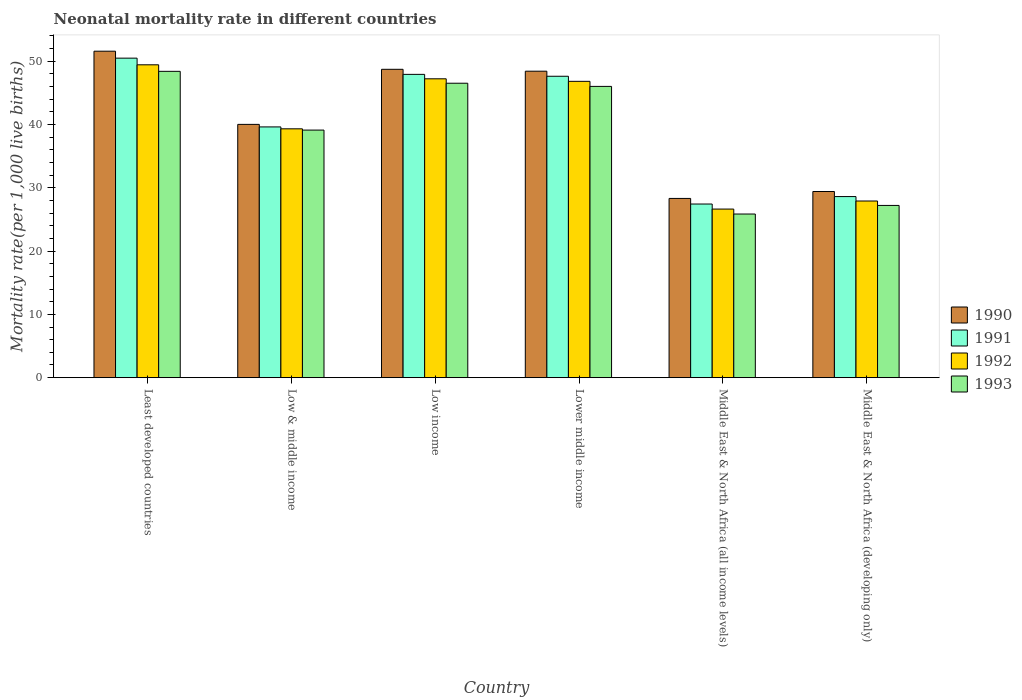Are the number of bars per tick equal to the number of legend labels?
Make the answer very short. Yes. Are the number of bars on each tick of the X-axis equal?
Keep it short and to the point. Yes. How many bars are there on the 4th tick from the left?
Make the answer very short. 4. How many bars are there on the 2nd tick from the right?
Keep it short and to the point. 4. What is the label of the 2nd group of bars from the left?
Keep it short and to the point. Low & middle income. In how many cases, is the number of bars for a given country not equal to the number of legend labels?
Give a very brief answer. 0. What is the neonatal mortality rate in 1992 in Middle East & North Africa (all income levels)?
Give a very brief answer. 26.63. Across all countries, what is the maximum neonatal mortality rate in 1992?
Ensure brevity in your answer.  49.41. Across all countries, what is the minimum neonatal mortality rate in 1990?
Your answer should be compact. 28.31. In which country was the neonatal mortality rate in 1991 maximum?
Ensure brevity in your answer.  Least developed countries. In which country was the neonatal mortality rate in 1990 minimum?
Your response must be concise. Middle East & North Africa (all income levels). What is the total neonatal mortality rate in 1990 in the graph?
Ensure brevity in your answer.  246.36. What is the difference between the neonatal mortality rate in 1993 in Low & middle income and that in Middle East & North Africa (developing only)?
Give a very brief answer. 11.9. What is the difference between the neonatal mortality rate in 1992 in Low income and the neonatal mortality rate in 1990 in Middle East & North Africa (developing only)?
Keep it short and to the point. 17.8. What is the average neonatal mortality rate in 1993 per country?
Keep it short and to the point. 38.84. What is the difference between the neonatal mortality rate of/in 1990 and neonatal mortality rate of/in 1993 in Middle East & North Africa (developing only)?
Your answer should be compact. 2.2. In how many countries, is the neonatal mortality rate in 1990 greater than 50?
Provide a succinct answer. 1. What is the ratio of the neonatal mortality rate in 1991 in Low income to that in Middle East & North Africa (all income levels)?
Your answer should be compact. 1.75. Is the neonatal mortality rate in 1992 in Lower middle income less than that in Middle East & North Africa (developing only)?
Provide a short and direct response. No. What is the difference between the highest and the second highest neonatal mortality rate in 1991?
Ensure brevity in your answer.  2.86. What is the difference between the highest and the lowest neonatal mortality rate in 1993?
Your answer should be very brief. 22.54. In how many countries, is the neonatal mortality rate in 1991 greater than the average neonatal mortality rate in 1991 taken over all countries?
Your answer should be very brief. 3. Is it the case that in every country, the sum of the neonatal mortality rate in 1993 and neonatal mortality rate in 1991 is greater than the sum of neonatal mortality rate in 1992 and neonatal mortality rate in 1990?
Provide a short and direct response. No. How many bars are there?
Ensure brevity in your answer.  24. How many countries are there in the graph?
Keep it short and to the point. 6. Are the values on the major ticks of Y-axis written in scientific E-notation?
Your answer should be very brief. No. Does the graph contain grids?
Give a very brief answer. No. How many legend labels are there?
Offer a very short reply. 4. How are the legend labels stacked?
Provide a short and direct response. Vertical. What is the title of the graph?
Offer a very short reply. Neonatal mortality rate in different countries. Does "2010" appear as one of the legend labels in the graph?
Keep it short and to the point. No. What is the label or title of the X-axis?
Provide a succinct answer. Country. What is the label or title of the Y-axis?
Your response must be concise. Mortality rate(per 1,0 live births). What is the Mortality rate(per 1,000 live births) of 1990 in Least developed countries?
Keep it short and to the point. 51.56. What is the Mortality rate(per 1,000 live births) of 1991 in Least developed countries?
Make the answer very short. 50.46. What is the Mortality rate(per 1,000 live births) of 1992 in Least developed countries?
Keep it short and to the point. 49.41. What is the Mortality rate(per 1,000 live births) in 1993 in Least developed countries?
Your response must be concise. 48.38. What is the Mortality rate(per 1,000 live births) in 1991 in Low & middle income?
Provide a succinct answer. 39.6. What is the Mortality rate(per 1,000 live births) in 1992 in Low & middle income?
Offer a terse response. 39.3. What is the Mortality rate(per 1,000 live births) of 1993 in Low & middle income?
Your answer should be compact. 39.1. What is the Mortality rate(per 1,000 live births) of 1990 in Low income?
Give a very brief answer. 48.7. What is the Mortality rate(per 1,000 live births) of 1991 in Low income?
Provide a short and direct response. 47.9. What is the Mortality rate(per 1,000 live births) of 1992 in Low income?
Provide a succinct answer. 47.2. What is the Mortality rate(per 1,000 live births) in 1993 in Low income?
Your answer should be compact. 46.5. What is the Mortality rate(per 1,000 live births) of 1990 in Lower middle income?
Provide a short and direct response. 48.4. What is the Mortality rate(per 1,000 live births) of 1991 in Lower middle income?
Your answer should be compact. 47.6. What is the Mortality rate(per 1,000 live births) of 1992 in Lower middle income?
Make the answer very short. 46.8. What is the Mortality rate(per 1,000 live births) in 1993 in Lower middle income?
Offer a terse response. 46. What is the Mortality rate(per 1,000 live births) in 1990 in Middle East & North Africa (all income levels)?
Keep it short and to the point. 28.31. What is the Mortality rate(per 1,000 live births) of 1991 in Middle East & North Africa (all income levels)?
Make the answer very short. 27.42. What is the Mortality rate(per 1,000 live births) of 1992 in Middle East & North Africa (all income levels)?
Give a very brief answer. 26.63. What is the Mortality rate(per 1,000 live births) of 1993 in Middle East & North Africa (all income levels)?
Provide a short and direct response. 25.84. What is the Mortality rate(per 1,000 live births) in 1990 in Middle East & North Africa (developing only)?
Your response must be concise. 29.4. What is the Mortality rate(per 1,000 live births) in 1991 in Middle East & North Africa (developing only)?
Your response must be concise. 28.6. What is the Mortality rate(per 1,000 live births) of 1992 in Middle East & North Africa (developing only)?
Make the answer very short. 27.9. What is the Mortality rate(per 1,000 live births) of 1993 in Middle East & North Africa (developing only)?
Give a very brief answer. 27.2. Across all countries, what is the maximum Mortality rate(per 1,000 live births) in 1990?
Provide a short and direct response. 51.56. Across all countries, what is the maximum Mortality rate(per 1,000 live births) of 1991?
Offer a terse response. 50.46. Across all countries, what is the maximum Mortality rate(per 1,000 live births) in 1992?
Offer a very short reply. 49.41. Across all countries, what is the maximum Mortality rate(per 1,000 live births) in 1993?
Your response must be concise. 48.38. Across all countries, what is the minimum Mortality rate(per 1,000 live births) of 1990?
Offer a terse response. 28.31. Across all countries, what is the minimum Mortality rate(per 1,000 live births) of 1991?
Provide a succinct answer. 27.42. Across all countries, what is the minimum Mortality rate(per 1,000 live births) in 1992?
Keep it short and to the point. 26.63. Across all countries, what is the minimum Mortality rate(per 1,000 live births) in 1993?
Your answer should be compact. 25.84. What is the total Mortality rate(per 1,000 live births) of 1990 in the graph?
Your answer should be compact. 246.36. What is the total Mortality rate(per 1,000 live births) of 1991 in the graph?
Make the answer very short. 241.59. What is the total Mortality rate(per 1,000 live births) of 1992 in the graph?
Ensure brevity in your answer.  237.23. What is the total Mortality rate(per 1,000 live births) of 1993 in the graph?
Your response must be concise. 233.02. What is the difference between the Mortality rate(per 1,000 live births) in 1990 in Least developed countries and that in Low & middle income?
Give a very brief answer. 11.56. What is the difference between the Mortality rate(per 1,000 live births) in 1991 in Least developed countries and that in Low & middle income?
Make the answer very short. 10.86. What is the difference between the Mortality rate(per 1,000 live births) of 1992 in Least developed countries and that in Low & middle income?
Offer a very short reply. 10.11. What is the difference between the Mortality rate(per 1,000 live births) of 1993 in Least developed countries and that in Low & middle income?
Offer a very short reply. 9.28. What is the difference between the Mortality rate(per 1,000 live births) in 1990 in Least developed countries and that in Low income?
Your response must be concise. 2.86. What is the difference between the Mortality rate(per 1,000 live births) in 1991 in Least developed countries and that in Low income?
Your answer should be very brief. 2.56. What is the difference between the Mortality rate(per 1,000 live births) of 1992 in Least developed countries and that in Low income?
Provide a succinct answer. 2.21. What is the difference between the Mortality rate(per 1,000 live births) in 1993 in Least developed countries and that in Low income?
Your answer should be very brief. 1.88. What is the difference between the Mortality rate(per 1,000 live births) in 1990 in Least developed countries and that in Lower middle income?
Your answer should be very brief. 3.16. What is the difference between the Mortality rate(per 1,000 live births) of 1991 in Least developed countries and that in Lower middle income?
Your response must be concise. 2.86. What is the difference between the Mortality rate(per 1,000 live births) of 1992 in Least developed countries and that in Lower middle income?
Provide a short and direct response. 2.61. What is the difference between the Mortality rate(per 1,000 live births) in 1993 in Least developed countries and that in Lower middle income?
Give a very brief answer. 2.38. What is the difference between the Mortality rate(per 1,000 live births) in 1990 in Least developed countries and that in Middle East & North Africa (all income levels)?
Your answer should be very brief. 23.25. What is the difference between the Mortality rate(per 1,000 live births) of 1991 in Least developed countries and that in Middle East & North Africa (all income levels)?
Offer a terse response. 23.04. What is the difference between the Mortality rate(per 1,000 live births) in 1992 in Least developed countries and that in Middle East & North Africa (all income levels)?
Provide a succinct answer. 22.78. What is the difference between the Mortality rate(per 1,000 live births) in 1993 in Least developed countries and that in Middle East & North Africa (all income levels)?
Offer a terse response. 22.54. What is the difference between the Mortality rate(per 1,000 live births) in 1990 in Least developed countries and that in Middle East & North Africa (developing only)?
Provide a succinct answer. 22.16. What is the difference between the Mortality rate(per 1,000 live births) in 1991 in Least developed countries and that in Middle East & North Africa (developing only)?
Provide a short and direct response. 21.86. What is the difference between the Mortality rate(per 1,000 live births) of 1992 in Least developed countries and that in Middle East & North Africa (developing only)?
Provide a succinct answer. 21.51. What is the difference between the Mortality rate(per 1,000 live births) in 1993 in Least developed countries and that in Middle East & North Africa (developing only)?
Provide a succinct answer. 21.18. What is the difference between the Mortality rate(per 1,000 live births) in 1990 in Low & middle income and that in Low income?
Keep it short and to the point. -8.7. What is the difference between the Mortality rate(per 1,000 live births) in 1991 in Low & middle income and that in Low income?
Make the answer very short. -8.3. What is the difference between the Mortality rate(per 1,000 live births) in 1992 in Low & middle income and that in Lower middle income?
Provide a short and direct response. -7.5. What is the difference between the Mortality rate(per 1,000 live births) of 1990 in Low & middle income and that in Middle East & North Africa (all income levels)?
Give a very brief answer. 11.69. What is the difference between the Mortality rate(per 1,000 live births) in 1991 in Low & middle income and that in Middle East & North Africa (all income levels)?
Give a very brief answer. 12.18. What is the difference between the Mortality rate(per 1,000 live births) of 1992 in Low & middle income and that in Middle East & North Africa (all income levels)?
Your response must be concise. 12.67. What is the difference between the Mortality rate(per 1,000 live births) in 1993 in Low & middle income and that in Middle East & North Africa (all income levels)?
Offer a terse response. 13.26. What is the difference between the Mortality rate(per 1,000 live births) in 1990 in Low & middle income and that in Middle East & North Africa (developing only)?
Your response must be concise. 10.6. What is the difference between the Mortality rate(per 1,000 live births) in 1991 in Low income and that in Lower middle income?
Your answer should be compact. 0.3. What is the difference between the Mortality rate(per 1,000 live births) in 1992 in Low income and that in Lower middle income?
Your answer should be compact. 0.4. What is the difference between the Mortality rate(per 1,000 live births) of 1993 in Low income and that in Lower middle income?
Provide a short and direct response. 0.5. What is the difference between the Mortality rate(per 1,000 live births) in 1990 in Low income and that in Middle East & North Africa (all income levels)?
Keep it short and to the point. 20.39. What is the difference between the Mortality rate(per 1,000 live births) in 1991 in Low income and that in Middle East & North Africa (all income levels)?
Provide a succinct answer. 20.48. What is the difference between the Mortality rate(per 1,000 live births) of 1992 in Low income and that in Middle East & North Africa (all income levels)?
Give a very brief answer. 20.57. What is the difference between the Mortality rate(per 1,000 live births) in 1993 in Low income and that in Middle East & North Africa (all income levels)?
Your answer should be very brief. 20.66. What is the difference between the Mortality rate(per 1,000 live births) in 1990 in Low income and that in Middle East & North Africa (developing only)?
Provide a succinct answer. 19.3. What is the difference between the Mortality rate(per 1,000 live births) of 1991 in Low income and that in Middle East & North Africa (developing only)?
Ensure brevity in your answer.  19.3. What is the difference between the Mortality rate(per 1,000 live births) of 1992 in Low income and that in Middle East & North Africa (developing only)?
Provide a succinct answer. 19.3. What is the difference between the Mortality rate(per 1,000 live births) of 1993 in Low income and that in Middle East & North Africa (developing only)?
Ensure brevity in your answer.  19.3. What is the difference between the Mortality rate(per 1,000 live births) of 1990 in Lower middle income and that in Middle East & North Africa (all income levels)?
Offer a terse response. 20.09. What is the difference between the Mortality rate(per 1,000 live births) in 1991 in Lower middle income and that in Middle East & North Africa (all income levels)?
Ensure brevity in your answer.  20.18. What is the difference between the Mortality rate(per 1,000 live births) in 1992 in Lower middle income and that in Middle East & North Africa (all income levels)?
Your answer should be very brief. 20.17. What is the difference between the Mortality rate(per 1,000 live births) of 1993 in Lower middle income and that in Middle East & North Africa (all income levels)?
Your answer should be very brief. 20.16. What is the difference between the Mortality rate(per 1,000 live births) of 1991 in Lower middle income and that in Middle East & North Africa (developing only)?
Make the answer very short. 19. What is the difference between the Mortality rate(per 1,000 live births) in 1992 in Lower middle income and that in Middle East & North Africa (developing only)?
Your response must be concise. 18.9. What is the difference between the Mortality rate(per 1,000 live births) of 1990 in Middle East & North Africa (all income levels) and that in Middle East & North Africa (developing only)?
Offer a terse response. -1.09. What is the difference between the Mortality rate(per 1,000 live births) in 1991 in Middle East & North Africa (all income levels) and that in Middle East & North Africa (developing only)?
Your answer should be compact. -1.18. What is the difference between the Mortality rate(per 1,000 live births) in 1992 in Middle East & North Africa (all income levels) and that in Middle East & North Africa (developing only)?
Your answer should be very brief. -1.27. What is the difference between the Mortality rate(per 1,000 live births) in 1993 in Middle East & North Africa (all income levels) and that in Middle East & North Africa (developing only)?
Your response must be concise. -1.36. What is the difference between the Mortality rate(per 1,000 live births) in 1990 in Least developed countries and the Mortality rate(per 1,000 live births) in 1991 in Low & middle income?
Give a very brief answer. 11.96. What is the difference between the Mortality rate(per 1,000 live births) in 1990 in Least developed countries and the Mortality rate(per 1,000 live births) in 1992 in Low & middle income?
Provide a short and direct response. 12.26. What is the difference between the Mortality rate(per 1,000 live births) of 1990 in Least developed countries and the Mortality rate(per 1,000 live births) of 1993 in Low & middle income?
Give a very brief answer. 12.46. What is the difference between the Mortality rate(per 1,000 live births) in 1991 in Least developed countries and the Mortality rate(per 1,000 live births) in 1992 in Low & middle income?
Your answer should be very brief. 11.16. What is the difference between the Mortality rate(per 1,000 live births) in 1991 in Least developed countries and the Mortality rate(per 1,000 live births) in 1993 in Low & middle income?
Your answer should be very brief. 11.36. What is the difference between the Mortality rate(per 1,000 live births) of 1992 in Least developed countries and the Mortality rate(per 1,000 live births) of 1993 in Low & middle income?
Offer a terse response. 10.31. What is the difference between the Mortality rate(per 1,000 live births) of 1990 in Least developed countries and the Mortality rate(per 1,000 live births) of 1991 in Low income?
Keep it short and to the point. 3.66. What is the difference between the Mortality rate(per 1,000 live births) of 1990 in Least developed countries and the Mortality rate(per 1,000 live births) of 1992 in Low income?
Give a very brief answer. 4.36. What is the difference between the Mortality rate(per 1,000 live births) in 1990 in Least developed countries and the Mortality rate(per 1,000 live births) in 1993 in Low income?
Offer a terse response. 5.06. What is the difference between the Mortality rate(per 1,000 live births) in 1991 in Least developed countries and the Mortality rate(per 1,000 live births) in 1992 in Low income?
Keep it short and to the point. 3.26. What is the difference between the Mortality rate(per 1,000 live births) of 1991 in Least developed countries and the Mortality rate(per 1,000 live births) of 1993 in Low income?
Your answer should be very brief. 3.96. What is the difference between the Mortality rate(per 1,000 live births) in 1992 in Least developed countries and the Mortality rate(per 1,000 live births) in 1993 in Low income?
Give a very brief answer. 2.91. What is the difference between the Mortality rate(per 1,000 live births) of 1990 in Least developed countries and the Mortality rate(per 1,000 live births) of 1991 in Lower middle income?
Offer a terse response. 3.96. What is the difference between the Mortality rate(per 1,000 live births) in 1990 in Least developed countries and the Mortality rate(per 1,000 live births) in 1992 in Lower middle income?
Provide a succinct answer. 4.76. What is the difference between the Mortality rate(per 1,000 live births) in 1990 in Least developed countries and the Mortality rate(per 1,000 live births) in 1993 in Lower middle income?
Your response must be concise. 5.56. What is the difference between the Mortality rate(per 1,000 live births) of 1991 in Least developed countries and the Mortality rate(per 1,000 live births) of 1992 in Lower middle income?
Your answer should be compact. 3.66. What is the difference between the Mortality rate(per 1,000 live births) of 1991 in Least developed countries and the Mortality rate(per 1,000 live births) of 1993 in Lower middle income?
Provide a succinct answer. 4.46. What is the difference between the Mortality rate(per 1,000 live births) in 1992 in Least developed countries and the Mortality rate(per 1,000 live births) in 1993 in Lower middle income?
Offer a very short reply. 3.41. What is the difference between the Mortality rate(per 1,000 live births) in 1990 in Least developed countries and the Mortality rate(per 1,000 live births) in 1991 in Middle East & North Africa (all income levels)?
Offer a terse response. 24.14. What is the difference between the Mortality rate(per 1,000 live births) in 1990 in Least developed countries and the Mortality rate(per 1,000 live births) in 1992 in Middle East & North Africa (all income levels)?
Ensure brevity in your answer.  24.93. What is the difference between the Mortality rate(per 1,000 live births) of 1990 in Least developed countries and the Mortality rate(per 1,000 live births) of 1993 in Middle East & North Africa (all income levels)?
Offer a terse response. 25.72. What is the difference between the Mortality rate(per 1,000 live births) of 1991 in Least developed countries and the Mortality rate(per 1,000 live births) of 1992 in Middle East & North Africa (all income levels)?
Provide a succinct answer. 23.84. What is the difference between the Mortality rate(per 1,000 live births) in 1991 in Least developed countries and the Mortality rate(per 1,000 live births) in 1993 in Middle East & North Africa (all income levels)?
Give a very brief answer. 24.62. What is the difference between the Mortality rate(per 1,000 live births) in 1992 in Least developed countries and the Mortality rate(per 1,000 live births) in 1993 in Middle East & North Africa (all income levels)?
Your answer should be very brief. 23.57. What is the difference between the Mortality rate(per 1,000 live births) of 1990 in Least developed countries and the Mortality rate(per 1,000 live births) of 1991 in Middle East & North Africa (developing only)?
Your answer should be very brief. 22.96. What is the difference between the Mortality rate(per 1,000 live births) in 1990 in Least developed countries and the Mortality rate(per 1,000 live births) in 1992 in Middle East & North Africa (developing only)?
Make the answer very short. 23.66. What is the difference between the Mortality rate(per 1,000 live births) in 1990 in Least developed countries and the Mortality rate(per 1,000 live births) in 1993 in Middle East & North Africa (developing only)?
Make the answer very short. 24.36. What is the difference between the Mortality rate(per 1,000 live births) in 1991 in Least developed countries and the Mortality rate(per 1,000 live births) in 1992 in Middle East & North Africa (developing only)?
Your answer should be very brief. 22.56. What is the difference between the Mortality rate(per 1,000 live births) of 1991 in Least developed countries and the Mortality rate(per 1,000 live births) of 1993 in Middle East & North Africa (developing only)?
Offer a very short reply. 23.26. What is the difference between the Mortality rate(per 1,000 live births) in 1992 in Least developed countries and the Mortality rate(per 1,000 live births) in 1993 in Middle East & North Africa (developing only)?
Keep it short and to the point. 22.21. What is the difference between the Mortality rate(per 1,000 live births) in 1990 in Low & middle income and the Mortality rate(per 1,000 live births) in 1992 in Low income?
Offer a terse response. -7.2. What is the difference between the Mortality rate(per 1,000 live births) in 1990 in Low & middle income and the Mortality rate(per 1,000 live births) in 1993 in Low income?
Offer a terse response. -6.5. What is the difference between the Mortality rate(per 1,000 live births) in 1991 in Low & middle income and the Mortality rate(per 1,000 live births) in 1992 in Low income?
Provide a short and direct response. -7.6. What is the difference between the Mortality rate(per 1,000 live births) in 1992 in Low & middle income and the Mortality rate(per 1,000 live births) in 1993 in Low income?
Ensure brevity in your answer.  -7.2. What is the difference between the Mortality rate(per 1,000 live births) in 1990 in Low & middle income and the Mortality rate(per 1,000 live births) in 1992 in Lower middle income?
Offer a very short reply. -6.8. What is the difference between the Mortality rate(per 1,000 live births) in 1991 in Low & middle income and the Mortality rate(per 1,000 live births) in 1992 in Lower middle income?
Ensure brevity in your answer.  -7.2. What is the difference between the Mortality rate(per 1,000 live births) of 1990 in Low & middle income and the Mortality rate(per 1,000 live births) of 1991 in Middle East & North Africa (all income levels)?
Make the answer very short. 12.58. What is the difference between the Mortality rate(per 1,000 live births) in 1990 in Low & middle income and the Mortality rate(per 1,000 live births) in 1992 in Middle East & North Africa (all income levels)?
Offer a terse response. 13.37. What is the difference between the Mortality rate(per 1,000 live births) in 1990 in Low & middle income and the Mortality rate(per 1,000 live births) in 1993 in Middle East & North Africa (all income levels)?
Offer a terse response. 14.16. What is the difference between the Mortality rate(per 1,000 live births) of 1991 in Low & middle income and the Mortality rate(per 1,000 live births) of 1992 in Middle East & North Africa (all income levels)?
Provide a succinct answer. 12.97. What is the difference between the Mortality rate(per 1,000 live births) of 1991 in Low & middle income and the Mortality rate(per 1,000 live births) of 1993 in Middle East & North Africa (all income levels)?
Ensure brevity in your answer.  13.76. What is the difference between the Mortality rate(per 1,000 live births) in 1992 in Low & middle income and the Mortality rate(per 1,000 live births) in 1993 in Middle East & North Africa (all income levels)?
Give a very brief answer. 13.46. What is the difference between the Mortality rate(per 1,000 live births) of 1990 in Low & middle income and the Mortality rate(per 1,000 live births) of 1991 in Middle East & North Africa (developing only)?
Offer a terse response. 11.4. What is the difference between the Mortality rate(per 1,000 live births) of 1990 in Low & middle income and the Mortality rate(per 1,000 live births) of 1993 in Middle East & North Africa (developing only)?
Your response must be concise. 12.8. What is the difference between the Mortality rate(per 1,000 live births) of 1992 in Low & middle income and the Mortality rate(per 1,000 live births) of 1993 in Middle East & North Africa (developing only)?
Provide a short and direct response. 12.1. What is the difference between the Mortality rate(per 1,000 live births) in 1990 in Low income and the Mortality rate(per 1,000 live births) in 1993 in Lower middle income?
Provide a succinct answer. 2.7. What is the difference between the Mortality rate(per 1,000 live births) of 1991 in Low income and the Mortality rate(per 1,000 live births) of 1992 in Lower middle income?
Your answer should be very brief. 1.1. What is the difference between the Mortality rate(per 1,000 live births) in 1991 in Low income and the Mortality rate(per 1,000 live births) in 1993 in Lower middle income?
Ensure brevity in your answer.  1.9. What is the difference between the Mortality rate(per 1,000 live births) in 1990 in Low income and the Mortality rate(per 1,000 live births) in 1991 in Middle East & North Africa (all income levels)?
Provide a short and direct response. 21.28. What is the difference between the Mortality rate(per 1,000 live births) in 1990 in Low income and the Mortality rate(per 1,000 live births) in 1992 in Middle East & North Africa (all income levels)?
Offer a very short reply. 22.07. What is the difference between the Mortality rate(per 1,000 live births) of 1990 in Low income and the Mortality rate(per 1,000 live births) of 1993 in Middle East & North Africa (all income levels)?
Provide a succinct answer. 22.86. What is the difference between the Mortality rate(per 1,000 live births) of 1991 in Low income and the Mortality rate(per 1,000 live births) of 1992 in Middle East & North Africa (all income levels)?
Your answer should be very brief. 21.27. What is the difference between the Mortality rate(per 1,000 live births) of 1991 in Low income and the Mortality rate(per 1,000 live births) of 1993 in Middle East & North Africa (all income levels)?
Your answer should be very brief. 22.06. What is the difference between the Mortality rate(per 1,000 live births) of 1992 in Low income and the Mortality rate(per 1,000 live births) of 1993 in Middle East & North Africa (all income levels)?
Provide a short and direct response. 21.36. What is the difference between the Mortality rate(per 1,000 live births) of 1990 in Low income and the Mortality rate(per 1,000 live births) of 1991 in Middle East & North Africa (developing only)?
Provide a short and direct response. 20.1. What is the difference between the Mortality rate(per 1,000 live births) of 1990 in Low income and the Mortality rate(per 1,000 live births) of 1992 in Middle East & North Africa (developing only)?
Make the answer very short. 20.8. What is the difference between the Mortality rate(per 1,000 live births) in 1990 in Low income and the Mortality rate(per 1,000 live births) in 1993 in Middle East & North Africa (developing only)?
Ensure brevity in your answer.  21.5. What is the difference between the Mortality rate(per 1,000 live births) of 1991 in Low income and the Mortality rate(per 1,000 live births) of 1993 in Middle East & North Africa (developing only)?
Your response must be concise. 20.7. What is the difference between the Mortality rate(per 1,000 live births) in 1990 in Lower middle income and the Mortality rate(per 1,000 live births) in 1991 in Middle East & North Africa (all income levels)?
Keep it short and to the point. 20.98. What is the difference between the Mortality rate(per 1,000 live births) of 1990 in Lower middle income and the Mortality rate(per 1,000 live births) of 1992 in Middle East & North Africa (all income levels)?
Your response must be concise. 21.77. What is the difference between the Mortality rate(per 1,000 live births) in 1990 in Lower middle income and the Mortality rate(per 1,000 live births) in 1993 in Middle East & North Africa (all income levels)?
Your answer should be compact. 22.56. What is the difference between the Mortality rate(per 1,000 live births) in 1991 in Lower middle income and the Mortality rate(per 1,000 live births) in 1992 in Middle East & North Africa (all income levels)?
Provide a short and direct response. 20.97. What is the difference between the Mortality rate(per 1,000 live births) in 1991 in Lower middle income and the Mortality rate(per 1,000 live births) in 1993 in Middle East & North Africa (all income levels)?
Provide a short and direct response. 21.76. What is the difference between the Mortality rate(per 1,000 live births) in 1992 in Lower middle income and the Mortality rate(per 1,000 live births) in 1993 in Middle East & North Africa (all income levels)?
Your answer should be very brief. 20.96. What is the difference between the Mortality rate(per 1,000 live births) in 1990 in Lower middle income and the Mortality rate(per 1,000 live births) in 1991 in Middle East & North Africa (developing only)?
Your response must be concise. 19.8. What is the difference between the Mortality rate(per 1,000 live births) of 1990 in Lower middle income and the Mortality rate(per 1,000 live births) of 1992 in Middle East & North Africa (developing only)?
Offer a terse response. 20.5. What is the difference between the Mortality rate(per 1,000 live births) of 1990 in Lower middle income and the Mortality rate(per 1,000 live births) of 1993 in Middle East & North Africa (developing only)?
Your response must be concise. 21.2. What is the difference between the Mortality rate(per 1,000 live births) of 1991 in Lower middle income and the Mortality rate(per 1,000 live births) of 1993 in Middle East & North Africa (developing only)?
Provide a succinct answer. 20.4. What is the difference between the Mortality rate(per 1,000 live births) of 1992 in Lower middle income and the Mortality rate(per 1,000 live births) of 1993 in Middle East & North Africa (developing only)?
Ensure brevity in your answer.  19.6. What is the difference between the Mortality rate(per 1,000 live births) in 1990 in Middle East & North Africa (all income levels) and the Mortality rate(per 1,000 live births) in 1991 in Middle East & North Africa (developing only)?
Make the answer very short. -0.29. What is the difference between the Mortality rate(per 1,000 live births) of 1990 in Middle East & North Africa (all income levels) and the Mortality rate(per 1,000 live births) of 1992 in Middle East & North Africa (developing only)?
Give a very brief answer. 0.41. What is the difference between the Mortality rate(per 1,000 live births) of 1990 in Middle East & North Africa (all income levels) and the Mortality rate(per 1,000 live births) of 1993 in Middle East & North Africa (developing only)?
Provide a succinct answer. 1.11. What is the difference between the Mortality rate(per 1,000 live births) in 1991 in Middle East & North Africa (all income levels) and the Mortality rate(per 1,000 live births) in 1992 in Middle East & North Africa (developing only)?
Offer a terse response. -0.48. What is the difference between the Mortality rate(per 1,000 live births) of 1991 in Middle East & North Africa (all income levels) and the Mortality rate(per 1,000 live births) of 1993 in Middle East & North Africa (developing only)?
Ensure brevity in your answer.  0.22. What is the difference between the Mortality rate(per 1,000 live births) of 1992 in Middle East & North Africa (all income levels) and the Mortality rate(per 1,000 live births) of 1993 in Middle East & North Africa (developing only)?
Ensure brevity in your answer.  -0.57. What is the average Mortality rate(per 1,000 live births) of 1990 per country?
Your answer should be compact. 41.06. What is the average Mortality rate(per 1,000 live births) of 1991 per country?
Provide a succinct answer. 40.26. What is the average Mortality rate(per 1,000 live births) in 1992 per country?
Give a very brief answer. 39.54. What is the average Mortality rate(per 1,000 live births) in 1993 per country?
Give a very brief answer. 38.84. What is the difference between the Mortality rate(per 1,000 live births) in 1990 and Mortality rate(per 1,000 live births) in 1991 in Least developed countries?
Your answer should be compact. 1.1. What is the difference between the Mortality rate(per 1,000 live births) of 1990 and Mortality rate(per 1,000 live births) of 1992 in Least developed countries?
Offer a terse response. 2.15. What is the difference between the Mortality rate(per 1,000 live births) in 1990 and Mortality rate(per 1,000 live births) in 1993 in Least developed countries?
Keep it short and to the point. 3.18. What is the difference between the Mortality rate(per 1,000 live births) of 1991 and Mortality rate(per 1,000 live births) of 1992 in Least developed countries?
Keep it short and to the point. 1.05. What is the difference between the Mortality rate(per 1,000 live births) of 1991 and Mortality rate(per 1,000 live births) of 1993 in Least developed countries?
Your answer should be very brief. 2.08. What is the difference between the Mortality rate(per 1,000 live births) of 1992 and Mortality rate(per 1,000 live births) of 1993 in Least developed countries?
Provide a short and direct response. 1.03. What is the difference between the Mortality rate(per 1,000 live births) of 1990 and Mortality rate(per 1,000 live births) of 1991 in Low & middle income?
Ensure brevity in your answer.  0.4. What is the difference between the Mortality rate(per 1,000 live births) of 1990 and Mortality rate(per 1,000 live births) of 1993 in Low & middle income?
Your response must be concise. 0.9. What is the difference between the Mortality rate(per 1,000 live births) of 1991 and Mortality rate(per 1,000 live births) of 1993 in Low & middle income?
Your answer should be very brief. 0.5. What is the difference between the Mortality rate(per 1,000 live births) in 1992 and Mortality rate(per 1,000 live births) in 1993 in Low & middle income?
Offer a terse response. 0.2. What is the difference between the Mortality rate(per 1,000 live births) of 1990 and Mortality rate(per 1,000 live births) of 1993 in Low income?
Your response must be concise. 2.2. What is the difference between the Mortality rate(per 1,000 live births) of 1991 and Mortality rate(per 1,000 live births) of 1992 in Low income?
Provide a short and direct response. 0.7. What is the difference between the Mortality rate(per 1,000 live births) in 1992 and Mortality rate(per 1,000 live births) in 1993 in Low income?
Provide a short and direct response. 0.7. What is the difference between the Mortality rate(per 1,000 live births) of 1990 and Mortality rate(per 1,000 live births) of 1991 in Lower middle income?
Give a very brief answer. 0.8. What is the difference between the Mortality rate(per 1,000 live births) in 1991 and Mortality rate(per 1,000 live births) in 1992 in Lower middle income?
Keep it short and to the point. 0.8. What is the difference between the Mortality rate(per 1,000 live births) in 1991 and Mortality rate(per 1,000 live births) in 1993 in Lower middle income?
Offer a terse response. 1.6. What is the difference between the Mortality rate(per 1,000 live births) of 1992 and Mortality rate(per 1,000 live births) of 1993 in Lower middle income?
Offer a very short reply. 0.8. What is the difference between the Mortality rate(per 1,000 live births) of 1990 and Mortality rate(per 1,000 live births) of 1991 in Middle East & North Africa (all income levels)?
Your response must be concise. 0.88. What is the difference between the Mortality rate(per 1,000 live births) in 1990 and Mortality rate(per 1,000 live births) in 1992 in Middle East & North Africa (all income levels)?
Offer a terse response. 1.68. What is the difference between the Mortality rate(per 1,000 live births) of 1990 and Mortality rate(per 1,000 live births) of 1993 in Middle East & North Africa (all income levels)?
Keep it short and to the point. 2.46. What is the difference between the Mortality rate(per 1,000 live births) of 1991 and Mortality rate(per 1,000 live births) of 1992 in Middle East & North Africa (all income levels)?
Your answer should be very brief. 0.8. What is the difference between the Mortality rate(per 1,000 live births) of 1991 and Mortality rate(per 1,000 live births) of 1993 in Middle East & North Africa (all income levels)?
Keep it short and to the point. 1.58. What is the difference between the Mortality rate(per 1,000 live births) in 1992 and Mortality rate(per 1,000 live births) in 1993 in Middle East & North Africa (all income levels)?
Offer a very short reply. 0.78. What is the difference between the Mortality rate(per 1,000 live births) of 1990 and Mortality rate(per 1,000 live births) of 1991 in Middle East & North Africa (developing only)?
Your answer should be compact. 0.8. What is the difference between the Mortality rate(per 1,000 live births) of 1990 and Mortality rate(per 1,000 live births) of 1993 in Middle East & North Africa (developing only)?
Provide a short and direct response. 2.2. What is the difference between the Mortality rate(per 1,000 live births) of 1991 and Mortality rate(per 1,000 live births) of 1993 in Middle East & North Africa (developing only)?
Provide a succinct answer. 1.4. What is the ratio of the Mortality rate(per 1,000 live births) of 1990 in Least developed countries to that in Low & middle income?
Keep it short and to the point. 1.29. What is the ratio of the Mortality rate(per 1,000 live births) of 1991 in Least developed countries to that in Low & middle income?
Ensure brevity in your answer.  1.27. What is the ratio of the Mortality rate(per 1,000 live births) in 1992 in Least developed countries to that in Low & middle income?
Your answer should be very brief. 1.26. What is the ratio of the Mortality rate(per 1,000 live births) in 1993 in Least developed countries to that in Low & middle income?
Provide a succinct answer. 1.24. What is the ratio of the Mortality rate(per 1,000 live births) of 1990 in Least developed countries to that in Low income?
Give a very brief answer. 1.06. What is the ratio of the Mortality rate(per 1,000 live births) of 1991 in Least developed countries to that in Low income?
Provide a succinct answer. 1.05. What is the ratio of the Mortality rate(per 1,000 live births) of 1992 in Least developed countries to that in Low income?
Provide a short and direct response. 1.05. What is the ratio of the Mortality rate(per 1,000 live births) of 1993 in Least developed countries to that in Low income?
Keep it short and to the point. 1.04. What is the ratio of the Mortality rate(per 1,000 live births) in 1990 in Least developed countries to that in Lower middle income?
Give a very brief answer. 1.07. What is the ratio of the Mortality rate(per 1,000 live births) of 1991 in Least developed countries to that in Lower middle income?
Give a very brief answer. 1.06. What is the ratio of the Mortality rate(per 1,000 live births) in 1992 in Least developed countries to that in Lower middle income?
Give a very brief answer. 1.06. What is the ratio of the Mortality rate(per 1,000 live births) of 1993 in Least developed countries to that in Lower middle income?
Provide a short and direct response. 1.05. What is the ratio of the Mortality rate(per 1,000 live births) of 1990 in Least developed countries to that in Middle East & North Africa (all income levels)?
Offer a very short reply. 1.82. What is the ratio of the Mortality rate(per 1,000 live births) in 1991 in Least developed countries to that in Middle East & North Africa (all income levels)?
Your response must be concise. 1.84. What is the ratio of the Mortality rate(per 1,000 live births) of 1992 in Least developed countries to that in Middle East & North Africa (all income levels)?
Provide a succinct answer. 1.86. What is the ratio of the Mortality rate(per 1,000 live births) in 1993 in Least developed countries to that in Middle East & North Africa (all income levels)?
Offer a terse response. 1.87. What is the ratio of the Mortality rate(per 1,000 live births) of 1990 in Least developed countries to that in Middle East & North Africa (developing only)?
Your response must be concise. 1.75. What is the ratio of the Mortality rate(per 1,000 live births) in 1991 in Least developed countries to that in Middle East & North Africa (developing only)?
Give a very brief answer. 1.76. What is the ratio of the Mortality rate(per 1,000 live births) of 1992 in Least developed countries to that in Middle East & North Africa (developing only)?
Your response must be concise. 1.77. What is the ratio of the Mortality rate(per 1,000 live births) in 1993 in Least developed countries to that in Middle East & North Africa (developing only)?
Make the answer very short. 1.78. What is the ratio of the Mortality rate(per 1,000 live births) in 1990 in Low & middle income to that in Low income?
Provide a short and direct response. 0.82. What is the ratio of the Mortality rate(per 1,000 live births) in 1991 in Low & middle income to that in Low income?
Your answer should be compact. 0.83. What is the ratio of the Mortality rate(per 1,000 live births) of 1992 in Low & middle income to that in Low income?
Your response must be concise. 0.83. What is the ratio of the Mortality rate(per 1,000 live births) of 1993 in Low & middle income to that in Low income?
Provide a short and direct response. 0.84. What is the ratio of the Mortality rate(per 1,000 live births) in 1990 in Low & middle income to that in Lower middle income?
Your answer should be very brief. 0.83. What is the ratio of the Mortality rate(per 1,000 live births) in 1991 in Low & middle income to that in Lower middle income?
Offer a terse response. 0.83. What is the ratio of the Mortality rate(per 1,000 live births) of 1992 in Low & middle income to that in Lower middle income?
Your response must be concise. 0.84. What is the ratio of the Mortality rate(per 1,000 live births) in 1993 in Low & middle income to that in Lower middle income?
Ensure brevity in your answer.  0.85. What is the ratio of the Mortality rate(per 1,000 live births) of 1990 in Low & middle income to that in Middle East & North Africa (all income levels)?
Keep it short and to the point. 1.41. What is the ratio of the Mortality rate(per 1,000 live births) of 1991 in Low & middle income to that in Middle East & North Africa (all income levels)?
Provide a succinct answer. 1.44. What is the ratio of the Mortality rate(per 1,000 live births) in 1992 in Low & middle income to that in Middle East & North Africa (all income levels)?
Offer a very short reply. 1.48. What is the ratio of the Mortality rate(per 1,000 live births) of 1993 in Low & middle income to that in Middle East & North Africa (all income levels)?
Give a very brief answer. 1.51. What is the ratio of the Mortality rate(per 1,000 live births) in 1990 in Low & middle income to that in Middle East & North Africa (developing only)?
Offer a very short reply. 1.36. What is the ratio of the Mortality rate(per 1,000 live births) of 1991 in Low & middle income to that in Middle East & North Africa (developing only)?
Provide a succinct answer. 1.38. What is the ratio of the Mortality rate(per 1,000 live births) of 1992 in Low & middle income to that in Middle East & North Africa (developing only)?
Your response must be concise. 1.41. What is the ratio of the Mortality rate(per 1,000 live births) in 1993 in Low & middle income to that in Middle East & North Africa (developing only)?
Give a very brief answer. 1.44. What is the ratio of the Mortality rate(per 1,000 live births) of 1992 in Low income to that in Lower middle income?
Your answer should be very brief. 1.01. What is the ratio of the Mortality rate(per 1,000 live births) of 1993 in Low income to that in Lower middle income?
Your response must be concise. 1.01. What is the ratio of the Mortality rate(per 1,000 live births) of 1990 in Low income to that in Middle East & North Africa (all income levels)?
Provide a succinct answer. 1.72. What is the ratio of the Mortality rate(per 1,000 live births) in 1991 in Low income to that in Middle East & North Africa (all income levels)?
Make the answer very short. 1.75. What is the ratio of the Mortality rate(per 1,000 live births) in 1992 in Low income to that in Middle East & North Africa (all income levels)?
Offer a very short reply. 1.77. What is the ratio of the Mortality rate(per 1,000 live births) of 1993 in Low income to that in Middle East & North Africa (all income levels)?
Your answer should be very brief. 1.8. What is the ratio of the Mortality rate(per 1,000 live births) of 1990 in Low income to that in Middle East & North Africa (developing only)?
Ensure brevity in your answer.  1.66. What is the ratio of the Mortality rate(per 1,000 live births) in 1991 in Low income to that in Middle East & North Africa (developing only)?
Ensure brevity in your answer.  1.67. What is the ratio of the Mortality rate(per 1,000 live births) in 1992 in Low income to that in Middle East & North Africa (developing only)?
Your answer should be compact. 1.69. What is the ratio of the Mortality rate(per 1,000 live births) in 1993 in Low income to that in Middle East & North Africa (developing only)?
Your answer should be very brief. 1.71. What is the ratio of the Mortality rate(per 1,000 live births) of 1990 in Lower middle income to that in Middle East & North Africa (all income levels)?
Offer a very short reply. 1.71. What is the ratio of the Mortality rate(per 1,000 live births) of 1991 in Lower middle income to that in Middle East & North Africa (all income levels)?
Your answer should be compact. 1.74. What is the ratio of the Mortality rate(per 1,000 live births) in 1992 in Lower middle income to that in Middle East & North Africa (all income levels)?
Offer a very short reply. 1.76. What is the ratio of the Mortality rate(per 1,000 live births) in 1993 in Lower middle income to that in Middle East & North Africa (all income levels)?
Your response must be concise. 1.78. What is the ratio of the Mortality rate(per 1,000 live births) of 1990 in Lower middle income to that in Middle East & North Africa (developing only)?
Provide a succinct answer. 1.65. What is the ratio of the Mortality rate(per 1,000 live births) in 1991 in Lower middle income to that in Middle East & North Africa (developing only)?
Give a very brief answer. 1.66. What is the ratio of the Mortality rate(per 1,000 live births) of 1992 in Lower middle income to that in Middle East & North Africa (developing only)?
Keep it short and to the point. 1.68. What is the ratio of the Mortality rate(per 1,000 live births) in 1993 in Lower middle income to that in Middle East & North Africa (developing only)?
Provide a short and direct response. 1.69. What is the ratio of the Mortality rate(per 1,000 live births) of 1990 in Middle East & North Africa (all income levels) to that in Middle East & North Africa (developing only)?
Keep it short and to the point. 0.96. What is the ratio of the Mortality rate(per 1,000 live births) in 1991 in Middle East & North Africa (all income levels) to that in Middle East & North Africa (developing only)?
Keep it short and to the point. 0.96. What is the ratio of the Mortality rate(per 1,000 live births) of 1992 in Middle East & North Africa (all income levels) to that in Middle East & North Africa (developing only)?
Your answer should be very brief. 0.95. What is the ratio of the Mortality rate(per 1,000 live births) in 1993 in Middle East & North Africa (all income levels) to that in Middle East & North Africa (developing only)?
Your answer should be compact. 0.95. What is the difference between the highest and the second highest Mortality rate(per 1,000 live births) in 1990?
Keep it short and to the point. 2.86. What is the difference between the highest and the second highest Mortality rate(per 1,000 live births) in 1991?
Your answer should be very brief. 2.56. What is the difference between the highest and the second highest Mortality rate(per 1,000 live births) in 1992?
Your answer should be compact. 2.21. What is the difference between the highest and the second highest Mortality rate(per 1,000 live births) in 1993?
Keep it short and to the point. 1.88. What is the difference between the highest and the lowest Mortality rate(per 1,000 live births) of 1990?
Give a very brief answer. 23.25. What is the difference between the highest and the lowest Mortality rate(per 1,000 live births) in 1991?
Your answer should be compact. 23.04. What is the difference between the highest and the lowest Mortality rate(per 1,000 live births) of 1992?
Your answer should be very brief. 22.78. What is the difference between the highest and the lowest Mortality rate(per 1,000 live births) of 1993?
Keep it short and to the point. 22.54. 